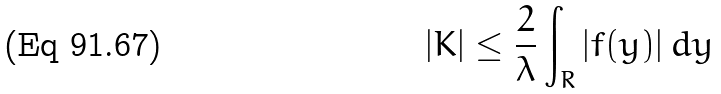Convert formula to latex. <formula><loc_0><loc_0><loc_500><loc_500>| K | \leq \frac { 2 } { \lambda } \int _ { R } | f ( y ) | \, d y</formula> 